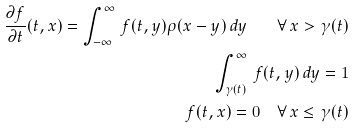<formula> <loc_0><loc_0><loc_500><loc_500>\frac { \partial f } { \partial t } ( t , x ) = \int _ { - \infty } ^ { \infty } \, f ( t , y ) \rho ( x - y ) \, d y \quad \forall \, x > \gamma ( t ) \\ \int _ { \gamma ( t ) } ^ { \infty } \, f ( t , y ) \, d y = 1 \\ f ( t , x ) = 0 \quad \forall \, x \leq \gamma ( t )</formula> 